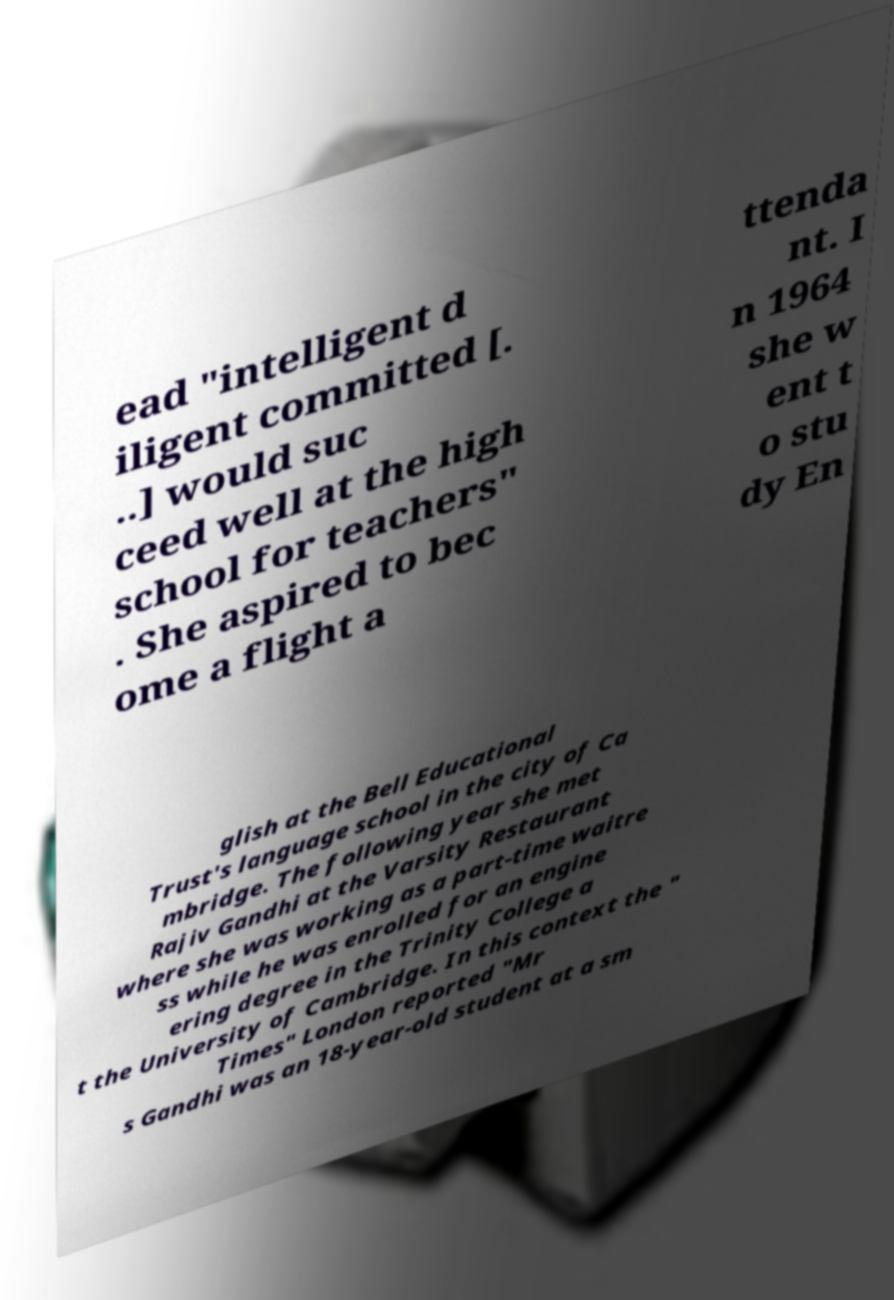What messages or text are displayed in this image? I need them in a readable, typed format. ead "intelligent d iligent committed [. ..] would suc ceed well at the high school for teachers" . She aspired to bec ome a flight a ttenda nt. I n 1964 she w ent t o stu dy En glish at the Bell Educational Trust's language school in the city of Ca mbridge. The following year she met Rajiv Gandhi at the Varsity Restaurant where she was working as a part-time waitre ss while he was enrolled for an engine ering degree in the Trinity College a t the University of Cambridge. In this context the " Times" London reported "Mr s Gandhi was an 18-year-old student at a sm 